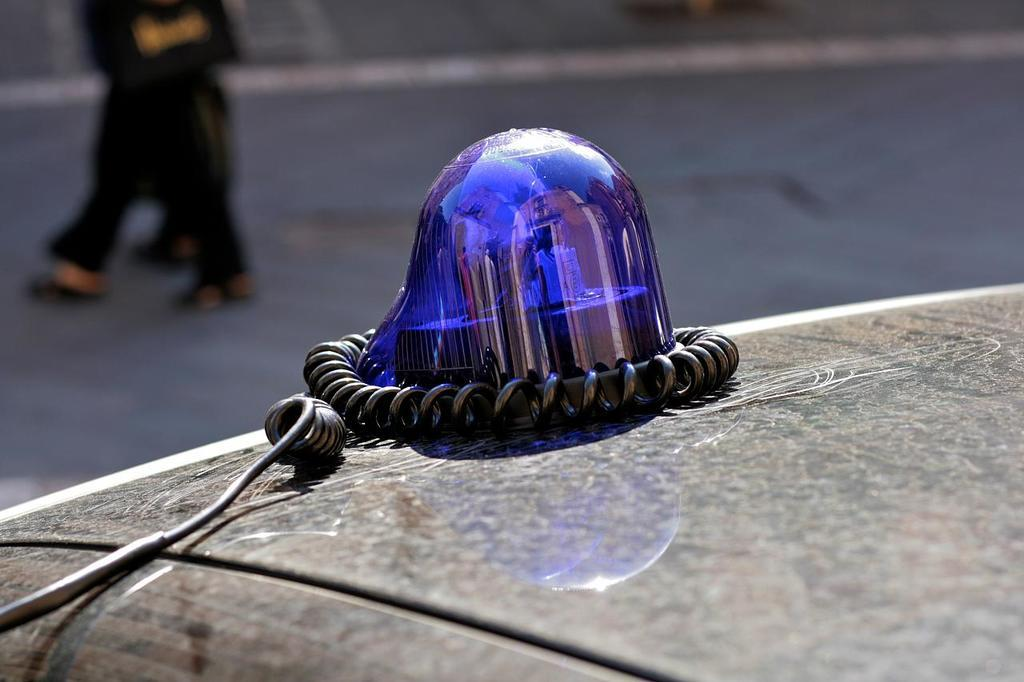What is the main object in the image? There is a revolving light bulb in the image. How is the light bulb connected to the vehicle? The light bulb is connected to a wire, which is fixed at the top of the vehicle. What can be seen in the background of the image? In the background, there is a person walking. What type of rabbit can be seen in the image? There is no rabbit present in the image. Where is the invention being used in the image? The provided facts do not mention any specific invention, so it cannot be determined where it might be used in the image. 